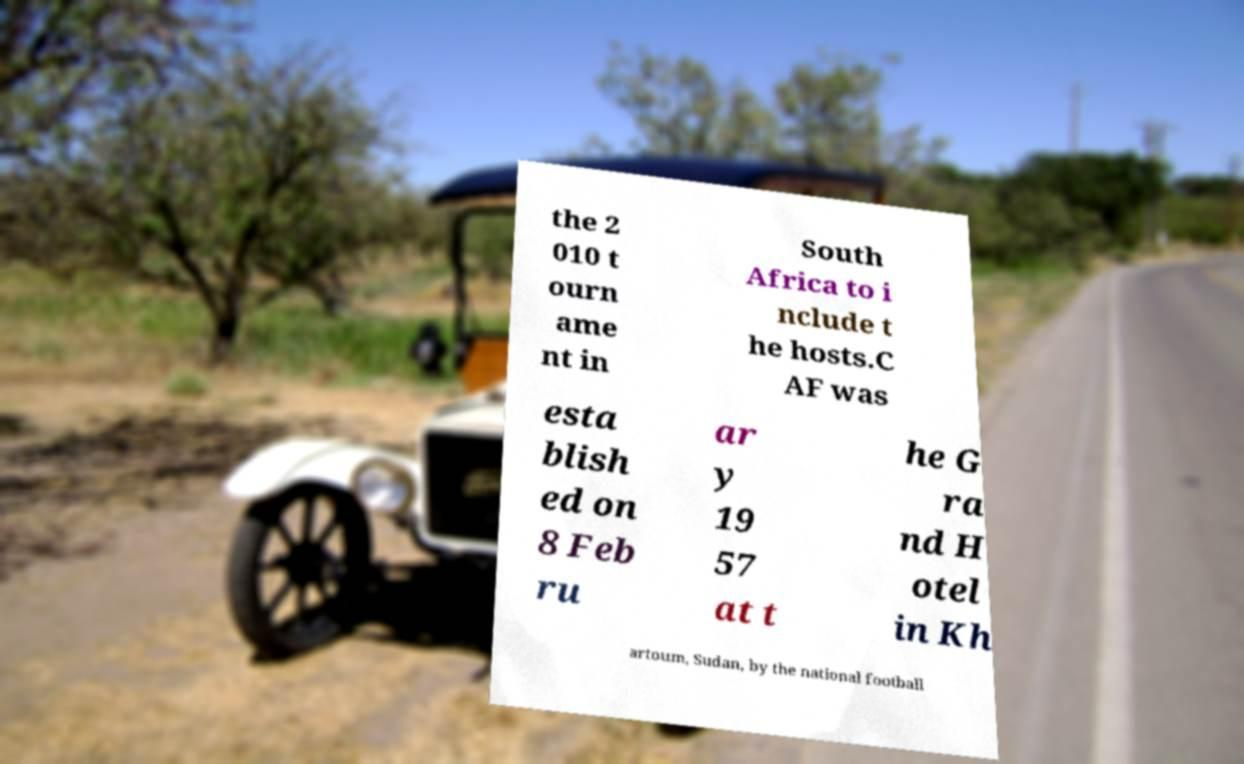What messages or text are displayed in this image? I need them in a readable, typed format. the 2 010 t ourn ame nt in South Africa to i nclude t he hosts.C AF was esta blish ed on 8 Feb ru ar y 19 57 at t he G ra nd H otel in Kh artoum, Sudan, by the national football 